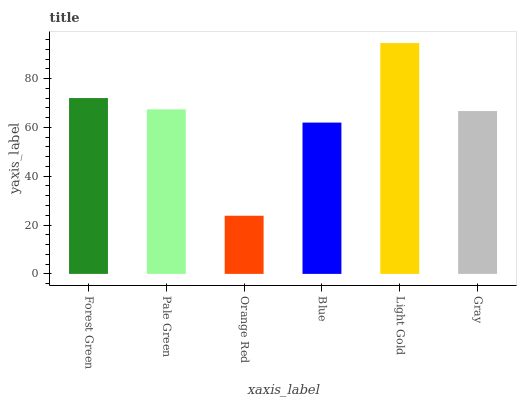Is Orange Red the minimum?
Answer yes or no. Yes. Is Light Gold the maximum?
Answer yes or no. Yes. Is Pale Green the minimum?
Answer yes or no. No. Is Pale Green the maximum?
Answer yes or no. No. Is Forest Green greater than Pale Green?
Answer yes or no. Yes. Is Pale Green less than Forest Green?
Answer yes or no. Yes. Is Pale Green greater than Forest Green?
Answer yes or no. No. Is Forest Green less than Pale Green?
Answer yes or no. No. Is Pale Green the high median?
Answer yes or no. Yes. Is Gray the low median?
Answer yes or no. Yes. Is Blue the high median?
Answer yes or no. No. Is Light Gold the low median?
Answer yes or no. No. 